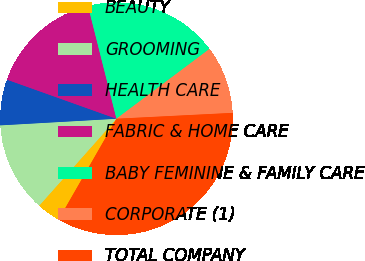Convert chart. <chart><loc_0><loc_0><loc_500><loc_500><pie_chart><fcel>BEAUTY<fcel>GROOMING<fcel>HEALTH CARE<fcel>FABRIC & HOME CARE<fcel>BABY FEMININE & FAMILY CARE<fcel>CORPORATE (1)<fcel>TOTAL COMPANY<nl><fcel>3.28%<fcel>12.53%<fcel>6.36%<fcel>15.61%<fcel>18.69%<fcel>9.44%<fcel>34.09%<nl></chart> 